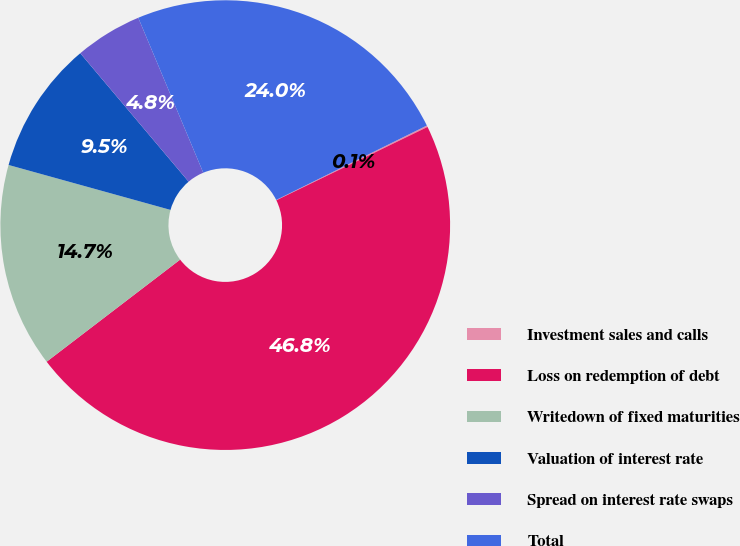Convert chart to OTSL. <chart><loc_0><loc_0><loc_500><loc_500><pie_chart><fcel>Investment sales and calls<fcel>Loss on redemption of debt<fcel>Writedown of fixed maturities<fcel>Valuation of interest rate<fcel>Spread on interest rate swaps<fcel>Total<nl><fcel>0.11%<fcel>46.8%<fcel>14.7%<fcel>9.54%<fcel>4.83%<fcel>24.02%<nl></chart> 